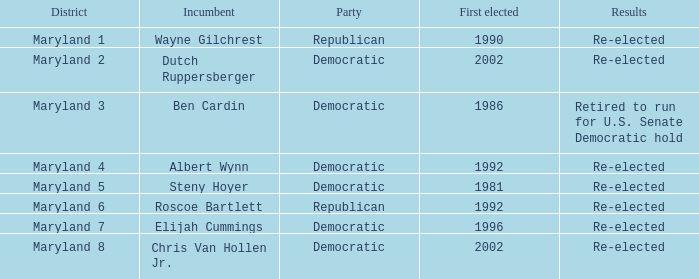What are the achievements of the sitting officeholder who was elected for the first time in 1996? Re-elected. 